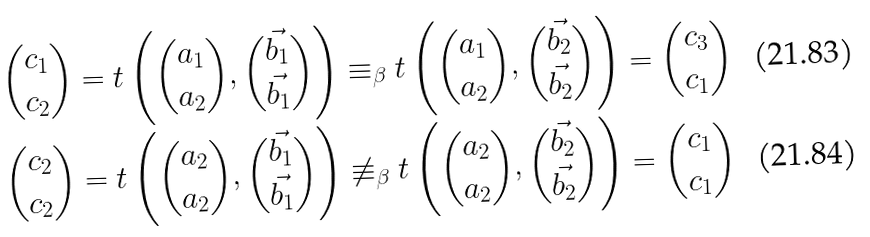<formula> <loc_0><loc_0><loc_500><loc_500>\binom { c _ { 1 } } { c _ { 2 } } = t \left ( \binom { a _ { 1 } } { a _ { 2 } } , \binom { \vec { b _ { 1 } } } { \vec { b _ { 1 } } } \right ) & \equiv _ { \beta } t \left ( \binom { a _ { 1 } } { a _ { 2 } } , \binom { \vec { b _ { 2 } } } { \vec { b _ { 2 } } } \right ) = \binom { c _ { 3 } } { c _ { 1 } } \\ \binom { c _ { 2 } } { c _ { 2 } } = t \left ( \binom { a _ { 2 } } { a _ { 2 } } , \binom { \vec { b _ { 1 } } } { \vec { b _ { 1 } } } \right ) & \not \equiv _ { \beta } t \left ( \binom { a _ { 2 } } { a _ { 2 } } , \binom { \vec { b _ { 2 } } } { \vec { b _ { 2 } } } \right ) = \binom { c _ { 1 } } { c _ { 1 } }</formula> 